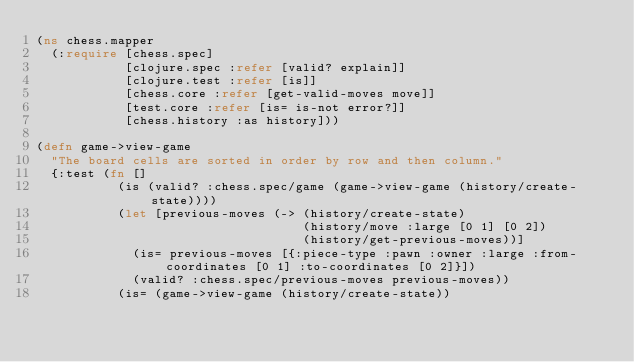<code> <loc_0><loc_0><loc_500><loc_500><_Clojure_>(ns chess.mapper
  (:require [chess.spec]
            [clojure.spec :refer [valid? explain]]
            [clojure.test :refer [is]]
            [chess.core :refer [get-valid-moves move]]
            [test.core :refer [is= is-not error?]]
            [chess.history :as history]))

(defn game->view-game
  "The board cells are sorted in order by row and then column."
  {:test (fn []
           (is (valid? :chess.spec/game (game->view-game (history/create-state))))
           (let [previous-moves (-> (history/create-state)
                                    (history/move :large [0 1] [0 2])
                                    (history/get-previous-moves))]
             (is= previous-moves [{:piece-type :pawn :owner :large :from-coordinates [0 1] :to-coordinates [0 2]}])
             (valid? :chess.spec/previous-moves previous-moves))
           (is= (game->view-game (history/create-state))</code> 